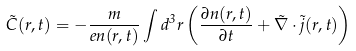Convert formula to latex. <formula><loc_0><loc_0><loc_500><loc_500>\vec { C } ( r , t ) = - \frac { m } { e n ( r , t ) } \int d ^ { 3 } r \left ( \frac { \partial n ( r , t ) } { \partial t } + \vec { \nabla } \cdot \vec { j } ( r , t ) \right )</formula> 